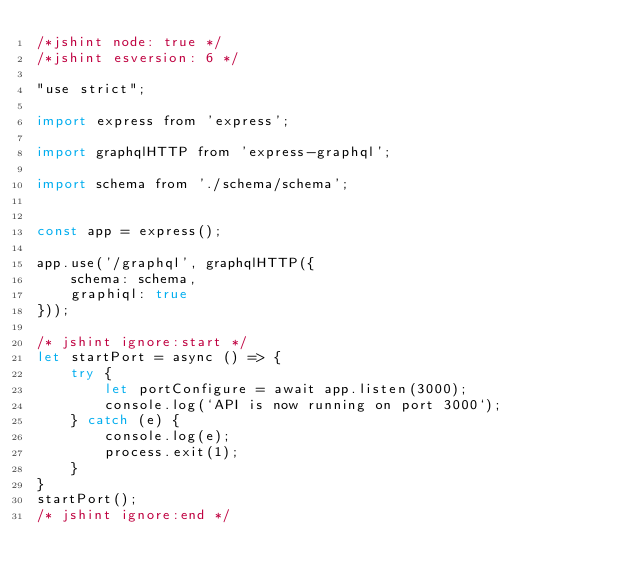<code> <loc_0><loc_0><loc_500><loc_500><_JavaScript_>/*jshint node: true */
/*jshint esversion: 6 */

"use strict";

import express from 'express';

import graphqlHTTP from 'express-graphql';

import schema from './schema/schema';


const app = express();

app.use('/graphql', graphqlHTTP({
    schema: schema,
    graphiql: true
}));

/* jshint ignore:start */
let startPort = async () => {
    try {
        let portConfigure = await app.listen(3000);
        console.log(`API is now running on port 3000`);
    } catch (e) {
        console.log(e);
        process.exit(1);
    }
}
startPort();
/* jshint ignore:end */



</code> 